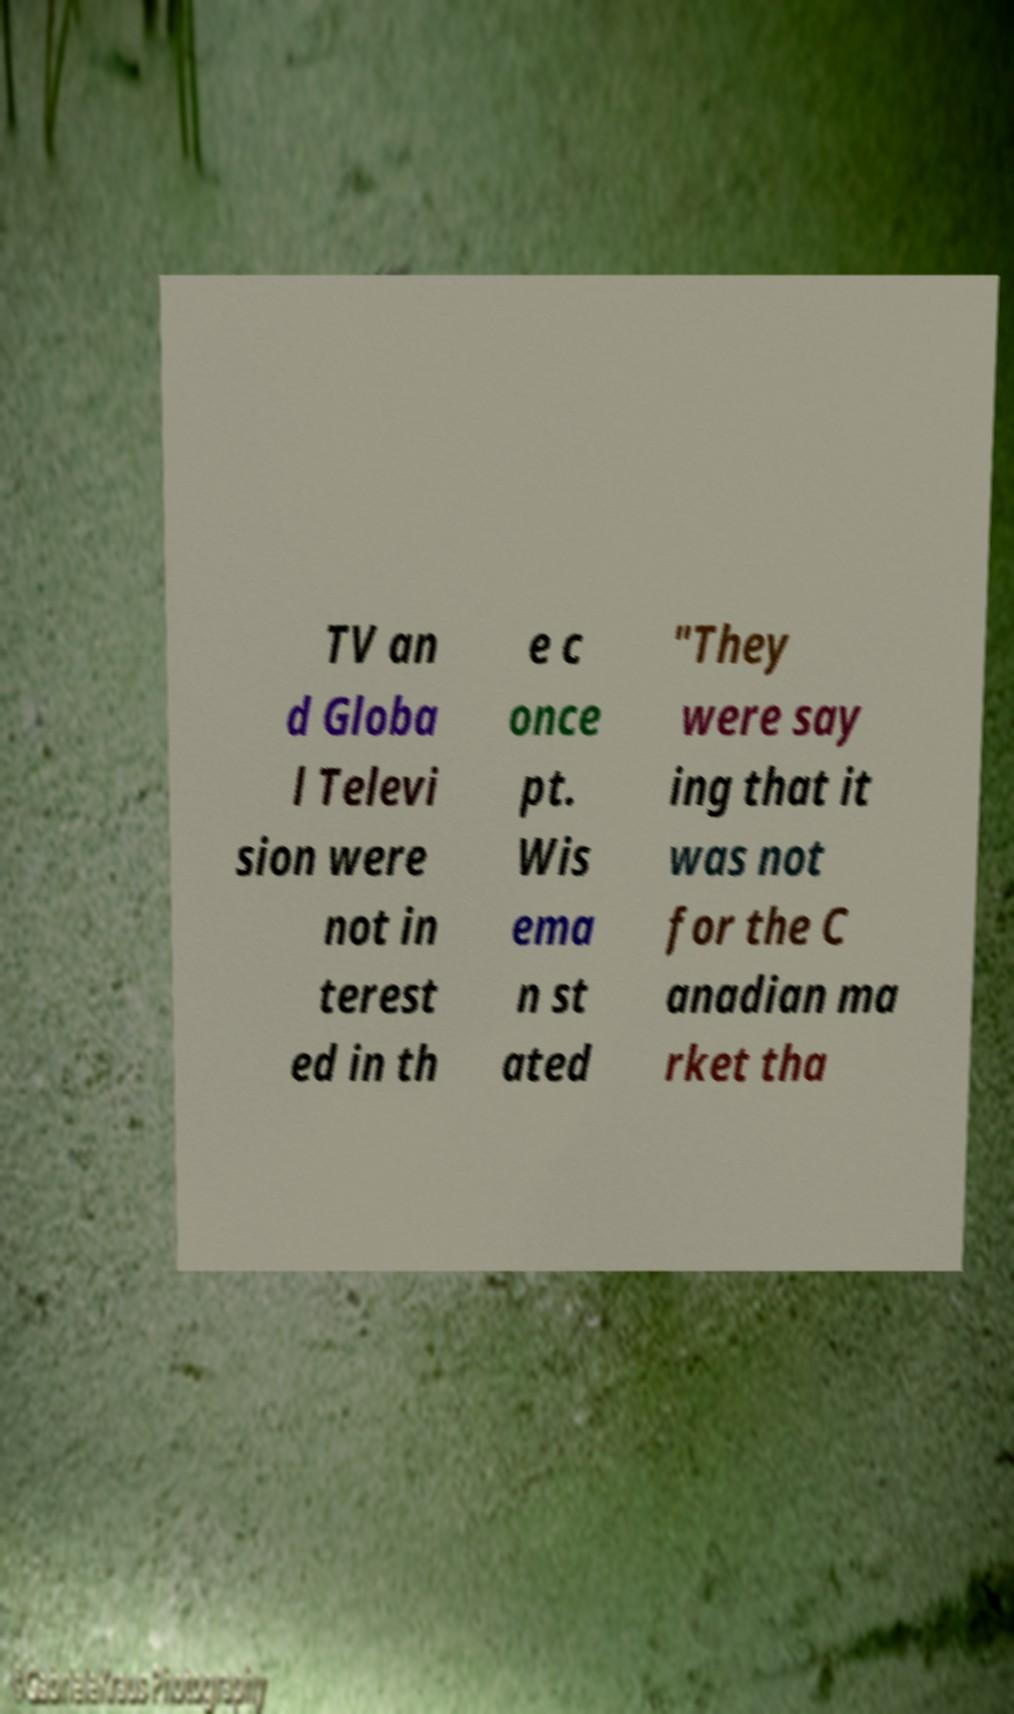Can you accurately transcribe the text from the provided image for me? TV an d Globa l Televi sion were not in terest ed in th e c once pt. Wis ema n st ated "They were say ing that it was not for the C anadian ma rket tha 